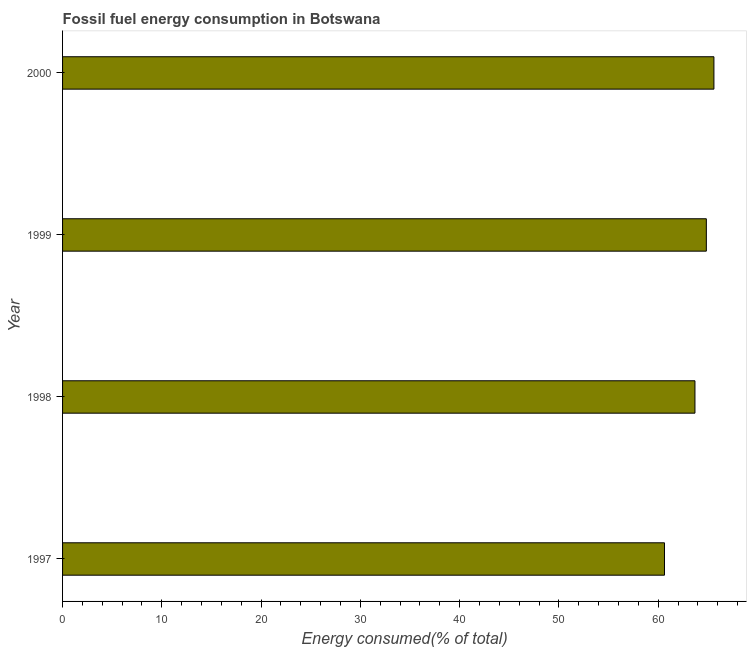Does the graph contain grids?
Provide a short and direct response. No. What is the title of the graph?
Give a very brief answer. Fossil fuel energy consumption in Botswana. What is the label or title of the X-axis?
Your response must be concise. Energy consumed(% of total). What is the fossil fuel energy consumption in 1997?
Ensure brevity in your answer.  60.63. Across all years, what is the maximum fossil fuel energy consumption?
Keep it short and to the point. 65.61. Across all years, what is the minimum fossil fuel energy consumption?
Make the answer very short. 60.63. What is the sum of the fossil fuel energy consumption?
Make the answer very short. 254.8. What is the difference between the fossil fuel energy consumption in 1997 and 2000?
Your answer should be very brief. -4.98. What is the average fossil fuel energy consumption per year?
Keep it short and to the point. 63.7. What is the median fossil fuel energy consumption?
Your answer should be compact. 64.28. Do a majority of the years between 1998 and 2000 (inclusive) have fossil fuel energy consumption greater than 56 %?
Keep it short and to the point. Yes. What is the ratio of the fossil fuel energy consumption in 1997 to that in 1998?
Your answer should be very brief. 0.95. Is the fossil fuel energy consumption in 1997 less than that in 2000?
Provide a succinct answer. Yes. What is the difference between the highest and the second highest fossil fuel energy consumption?
Provide a succinct answer. 0.76. What is the difference between the highest and the lowest fossil fuel energy consumption?
Make the answer very short. 4.98. How many bars are there?
Provide a short and direct response. 4. Are the values on the major ticks of X-axis written in scientific E-notation?
Provide a short and direct response. No. What is the Energy consumed(% of total) in 1997?
Your response must be concise. 60.63. What is the Energy consumed(% of total) in 1998?
Your answer should be very brief. 63.7. What is the Energy consumed(% of total) of 1999?
Give a very brief answer. 64.85. What is the Energy consumed(% of total) in 2000?
Keep it short and to the point. 65.61. What is the difference between the Energy consumed(% of total) in 1997 and 1998?
Provide a succinct answer. -3.07. What is the difference between the Energy consumed(% of total) in 1997 and 1999?
Offer a very short reply. -4.22. What is the difference between the Energy consumed(% of total) in 1997 and 2000?
Ensure brevity in your answer.  -4.98. What is the difference between the Energy consumed(% of total) in 1998 and 1999?
Provide a succinct answer. -1.15. What is the difference between the Energy consumed(% of total) in 1998 and 2000?
Ensure brevity in your answer.  -1.91. What is the difference between the Energy consumed(% of total) in 1999 and 2000?
Provide a succinct answer. -0.76. What is the ratio of the Energy consumed(% of total) in 1997 to that in 1999?
Give a very brief answer. 0.94. What is the ratio of the Energy consumed(% of total) in 1997 to that in 2000?
Your answer should be compact. 0.92. What is the ratio of the Energy consumed(% of total) in 1998 to that in 1999?
Give a very brief answer. 0.98. What is the ratio of the Energy consumed(% of total) in 1998 to that in 2000?
Give a very brief answer. 0.97. What is the ratio of the Energy consumed(% of total) in 1999 to that in 2000?
Make the answer very short. 0.99. 